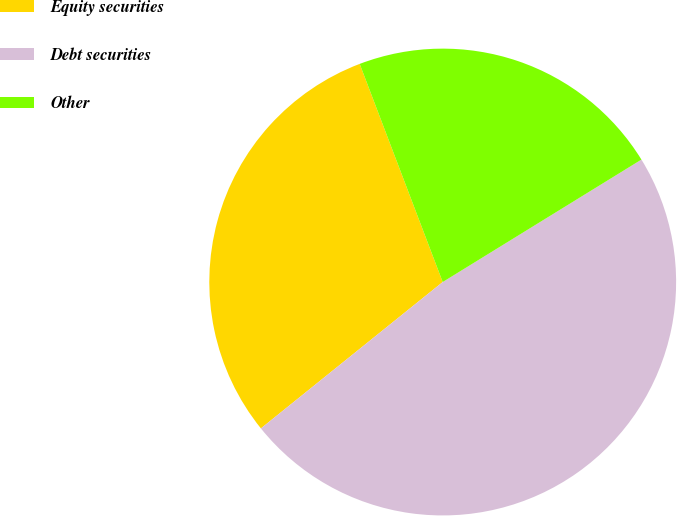Convert chart. <chart><loc_0><loc_0><loc_500><loc_500><pie_chart><fcel>Equity securities<fcel>Debt securities<fcel>Other<nl><fcel>30.0%<fcel>48.0%<fcel>22.0%<nl></chart> 